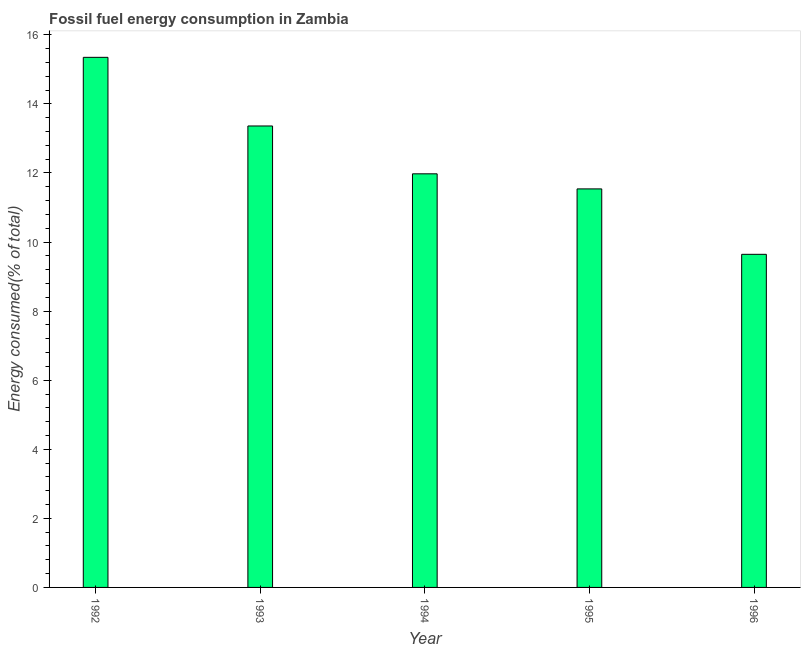Does the graph contain any zero values?
Provide a succinct answer. No. Does the graph contain grids?
Your response must be concise. No. What is the title of the graph?
Keep it short and to the point. Fossil fuel energy consumption in Zambia. What is the label or title of the X-axis?
Provide a succinct answer. Year. What is the label or title of the Y-axis?
Offer a terse response. Energy consumed(% of total). What is the fossil fuel energy consumption in 1994?
Ensure brevity in your answer.  11.98. Across all years, what is the maximum fossil fuel energy consumption?
Your answer should be compact. 15.35. Across all years, what is the minimum fossil fuel energy consumption?
Make the answer very short. 9.65. What is the sum of the fossil fuel energy consumption?
Provide a succinct answer. 61.87. What is the difference between the fossil fuel energy consumption in 1993 and 1995?
Offer a very short reply. 1.82. What is the average fossil fuel energy consumption per year?
Make the answer very short. 12.37. What is the median fossil fuel energy consumption?
Give a very brief answer. 11.98. In how many years, is the fossil fuel energy consumption greater than 13.6 %?
Give a very brief answer. 1. Do a majority of the years between 1995 and 1996 (inclusive) have fossil fuel energy consumption greater than 3.6 %?
Offer a terse response. Yes. What is the ratio of the fossil fuel energy consumption in 1992 to that in 1996?
Your answer should be very brief. 1.59. Is the fossil fuel energy consumption in 1993 less than that in 1996?
Keep it short and to the point. No. What is the difference between the highest and the second highest fossil fuel energy consumption?
Offer a terse response. 1.99. What is the Energy consumed(% of total) in 1992?
Your answer should be compact. 15.35. What is the Energy consumed(% of total) of 1993?
Ensure brevity in your answer.  13.36. What is the Energy consumed(% of total) in 1994?
Make the answer very short. 11.98. What is the Energy consumed(% of total) of 1995?
Provide a short and direct response. 11.54. What is the Energy consumed(% of total) in 1996?
Make the answer very short. 9.65. What is the difference between the Energy consumed(% of total) in 1992 and 1993?
Make the answer very short. 1.99. What is the difference between the Energy consumed(% of total) in 1992 and 1994?
Ensure brevity in your answer.  3.37. What is the difference between the Energy consumed(% of total) in 1992 and 1995?
Offer a very short reply. 3.81. What is the difference between the Energy consumed(% of total) in 1992 and 1996?
Offer a very short reply. 5.7. What is the difference between the Energy consumed(% of total) in 1993 and 1994?
Ensure brevity in your answer.  1.39. What is the difference between the Energy consumed(% of total) in 1993 and 1995?
Give a very brief answer. 1.82. What is the difference between the Energy consumed(% of total) in 1993 and 1996?
Your response must be concise. 3.72. What is the difference between the Energy consumed(% of total) in 1994 and 1995?
Keep it short and to the point. 0.44. What is the difference between the Energy consumed(% of total) in 1994 and 1996?
Your answer should be very brief. 2.33. What is the difference between the Energy consumed(% of total) in 1995 and 1996?
Ensure brevity in your answer.  1.89. What is the ratio of the Energy consumed(% of total) in 1992 to that in 1993?
Your answer should be compact. 1.15. What is the ratio of the Energy consumed(% of total) in 1992 to that in 1994?
Provide a short and direct response. 1.28. What is the ratio of the Energy consumed(% of total) in 1992 to that in 1995?
Your response must be concise. 1.33. What is the ratio of the Energy consumed(% of total) in 1992 to that in 1996?
Ensure brevity in your answer.  1.59. What is the ratio of the Energy consumed(% of total) in 1993 to that in 1994?
Make the answer very short. 1.12. What is the ratio of the Energy consumed(% of total) in 1993 to that in 1995?
Provide a succinct answer. 1.16. What is the ratio of the Energy consumed(% of total) in 1993 to that in 1996?
Keep it short and to the point. 1.39. What is the ratio of the Energy consumed(% of total) in 1994 to that in 1995?
Your answer should be very brief. 1.04. What is the ratio of the Energy consumed(% of total) in 1994 to that in 1996?
Offer a terse response. 1.24. What is the ratio of the Energy consumed(% of total) in 1995 to that in 1996?
Give a very brief answer. 1.2. 